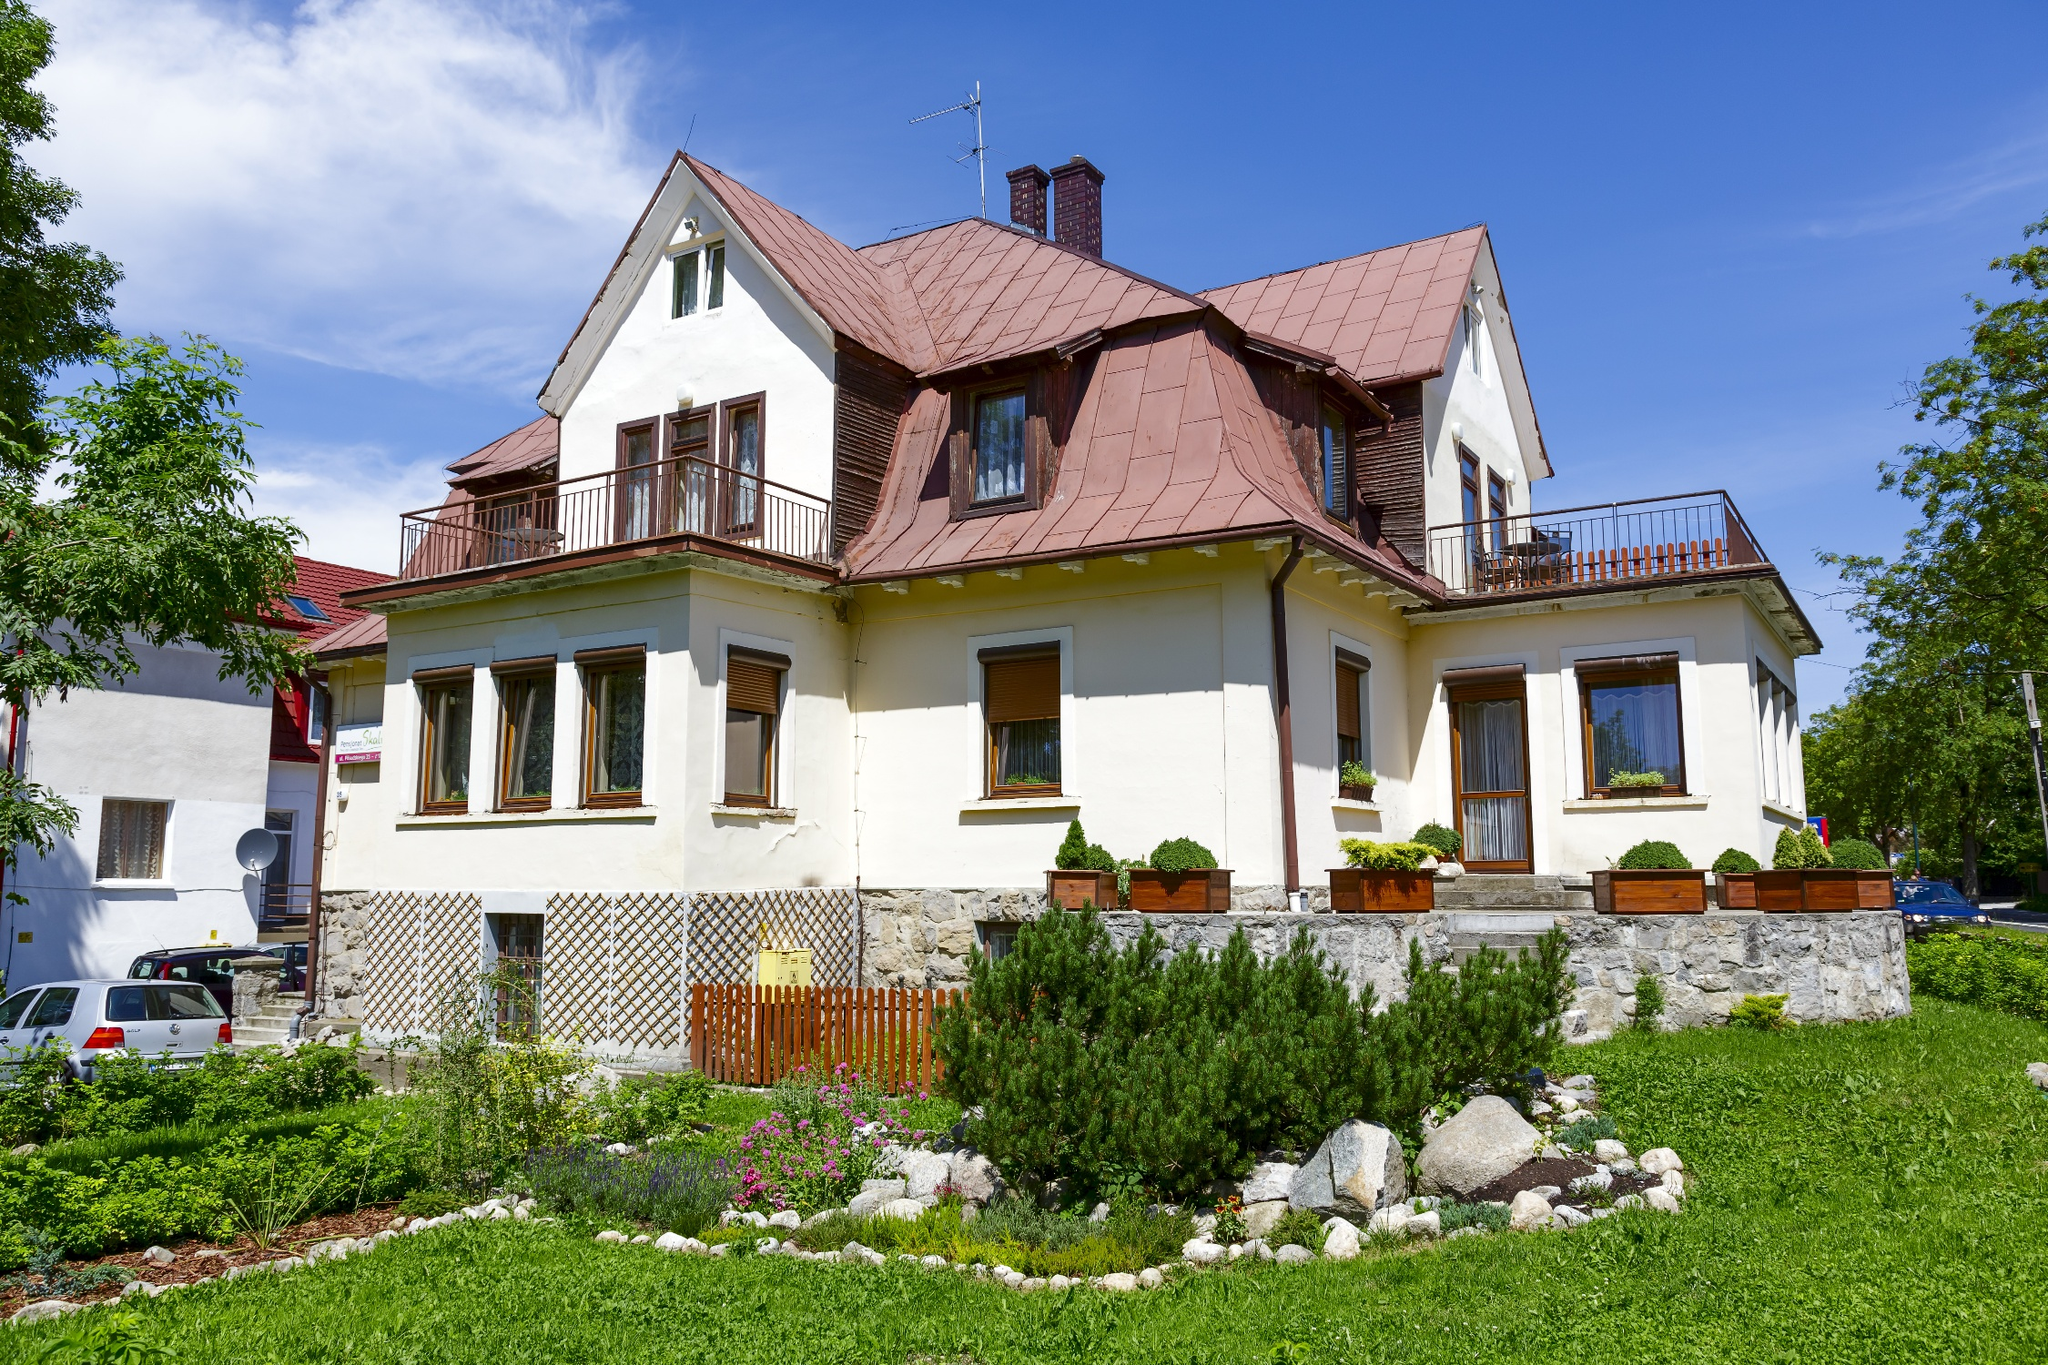What do you see happening in this image? The image presents a picturesque two-story house painted in bright white, contrasting beautifully with its vibrant red roof, set against a backdrop of a clear blue sky speckled with a few clouds. The architecture is simple yet elegant, featuring a balcony on the second floor and a welcoming porch below. The house is surrounded by a lush garden with a variety of plants and a neatly manicured lawn, suggesting a well-maintained property. This setting not only enhances the aesthetic appeal of the house but also offers a tranquil environment, ideal for residence or leisure. The image, with its clear, sunny weather and well-kept garden, also implies that the house is located in a temperate climate zone, making it a desirable location for relaxation and comfort. 